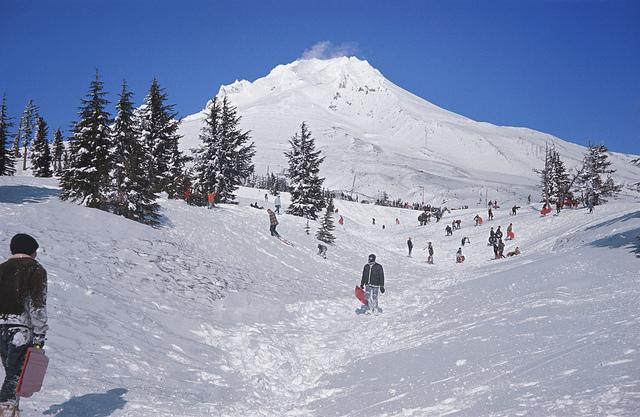How many people are skiing?
Give a very brief answer. 0. Is that snow drifting or a cloud at the top of the mountain?
Keep it brief. Cloud. Is the person looking uphill or downhill?
Concise answer only. Downhill. Is this a sunny day?
Short answer required. Yes. Is this man dressed appropriately?
Be succinct. Yes. Does this person appear to be snowshoeing?
Short answer required. No. What are the people holding?
Write a very short answer. Sleds. 